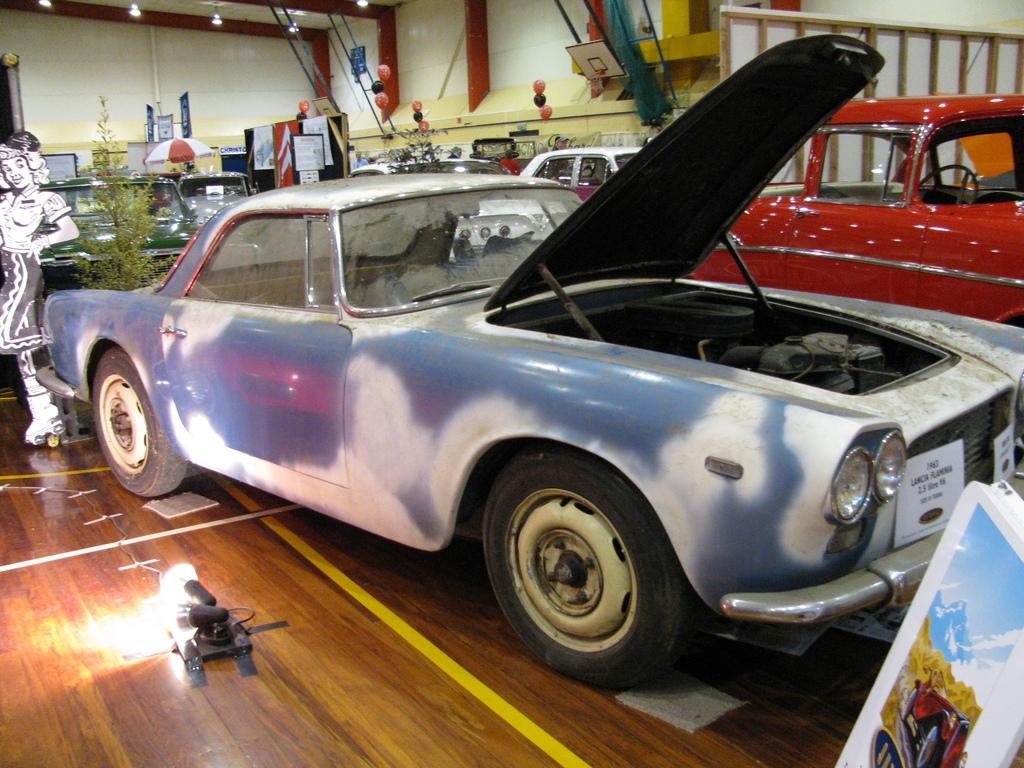Describe this image in one or two sentences. In this image I can see number of cars, number of plants, number of boards and I can also see number of balloons in the background. On the top left side and on the bottom left side of this image I can see number of lights. 